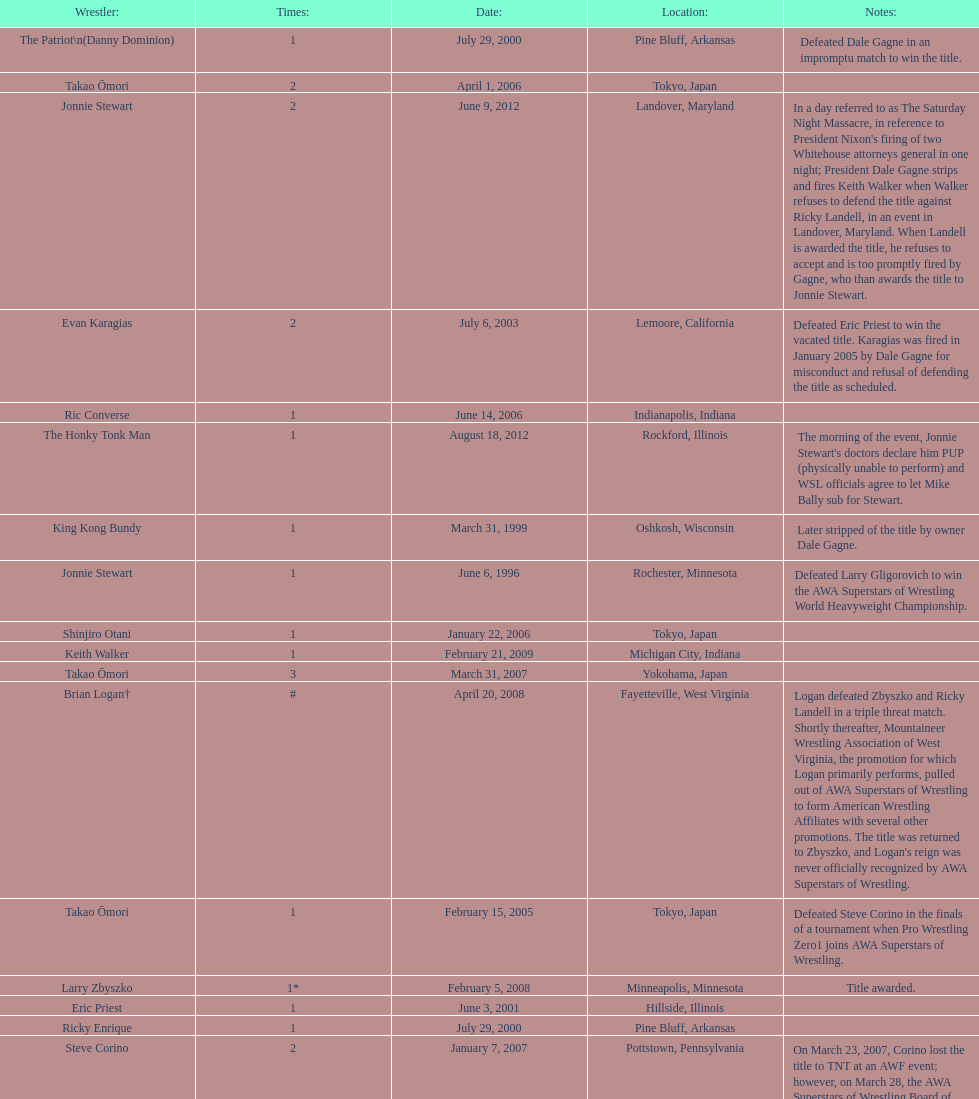How many times has ricky landell held the wsl title? 1. 